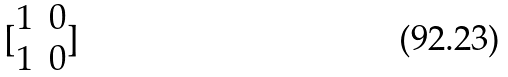<formula> <loc_0><loc_0><loc_500><loc_500>[ \begin{matrix} 1 & 0 \\ 1 & 0 \end{matrix} ]</formula> 